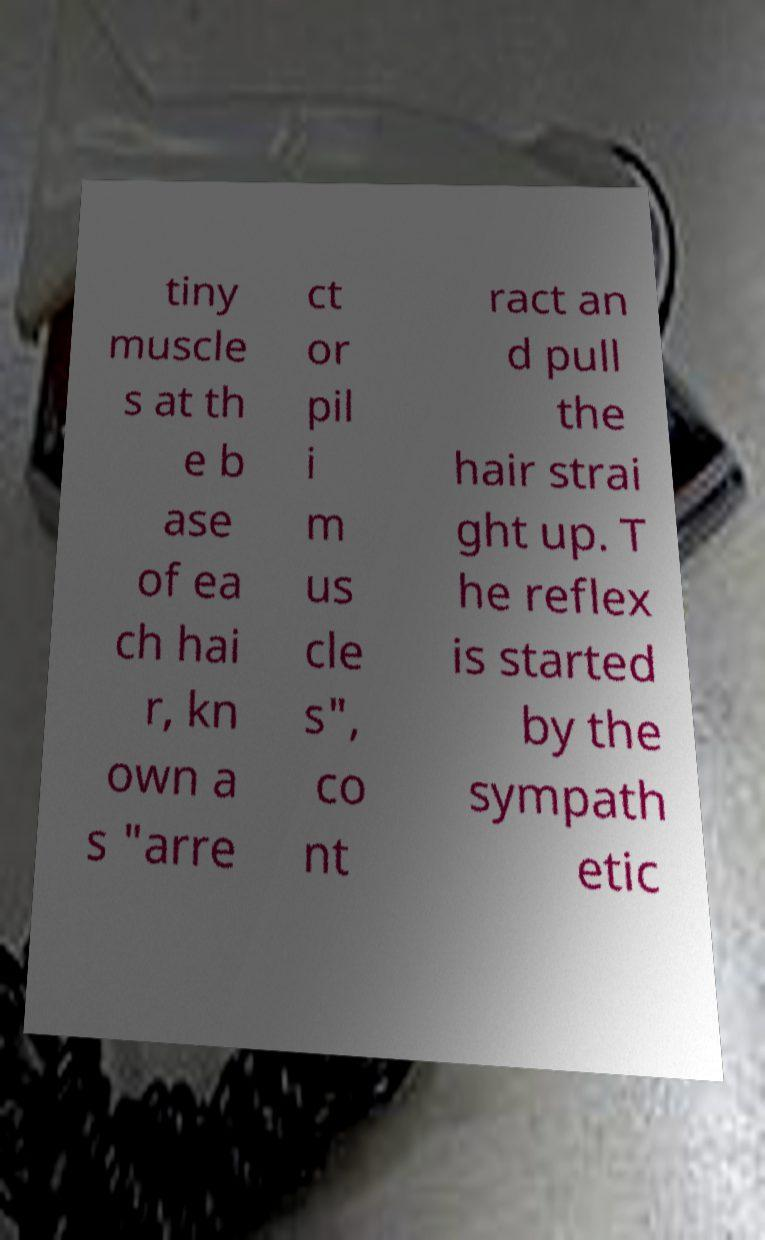Please read and relay the text visible in this image. What does it say? tiny muscle s at th e b ase of ea ch hai r, kn own a s "arre ct or pil i m us cle s", co nt ract an d pull the hair strai ght up. T he reflex is started by the sympath etic 